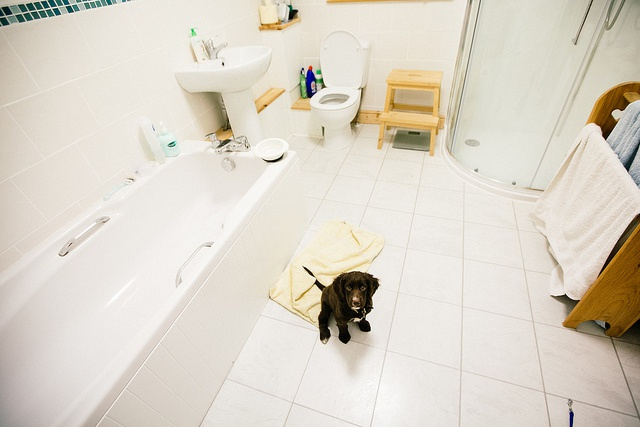Describe the objects in this image and their specific colors. I can see toilet in darkgray, lightgray, beige, and tan tones, dog in darkgray, black, olive, and ivory tones, sink in darkgray, white, lightgray, and tan tones, bench in darkgray, tan, and orange tones, and bench in darkgray and tan tones in this image. 